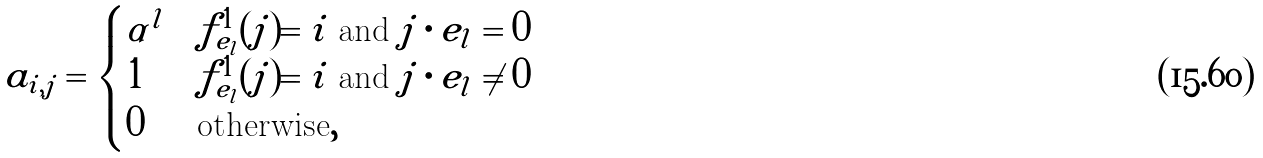Convert formula to latex. <formula><loc_0><loc_0><loc_500><loc_500>a _ { i , j } = \begin{cases} \alpha ^ { l } & f _ { e _ { l } } ^ { 1 } ( j ) = i \text { and } j \cdot e _ { l } = 0 \\ 1 & f _ { e _ { l } } ^ { 1 } ( j ) = i \text { and } j \cdot e _ { l } \neq 0 \\ 0 & \text {otherwise} , \end{cases}</formula> 